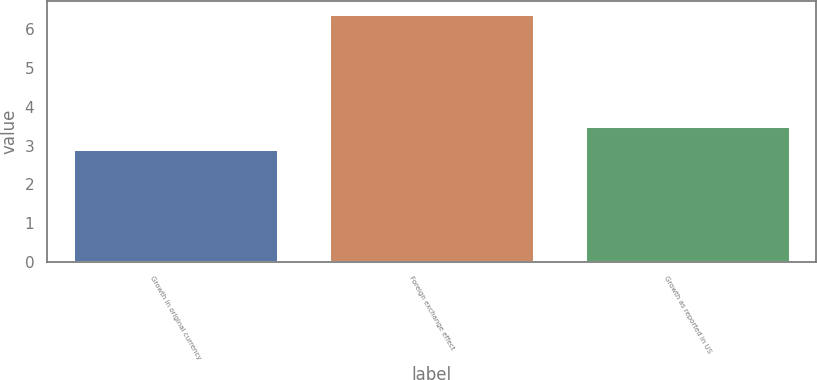Convert chart to OTSL. <chart><loc_0><loc_0><loc_500><loc_500><bar_chart><fcel>Growth in original currency<fcel>Foreign exchange effect<fcel>Growth as reported in US<nl><fcel>2.9<fcel>6.4<fcel>3.5<nl></chart> 